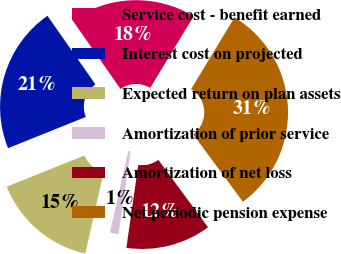Convert chart to OTSL. <chart><loc_0><loc_0><loc_500><loc_500><pie_chart><fcel>Service cost - benefit earned<fcel>Interest cost on projected<fcel>Expected return on plan assets<fcel>Amortization of prior service<fcel>Amortization of net loss<fcel>Net periodic pension expense<nl><fcel>18.38%<fcel>21.37%<fcel>15.38%<fcel>1.27%<fcel>12.38%<fcel>31.22%<nl></chart> 